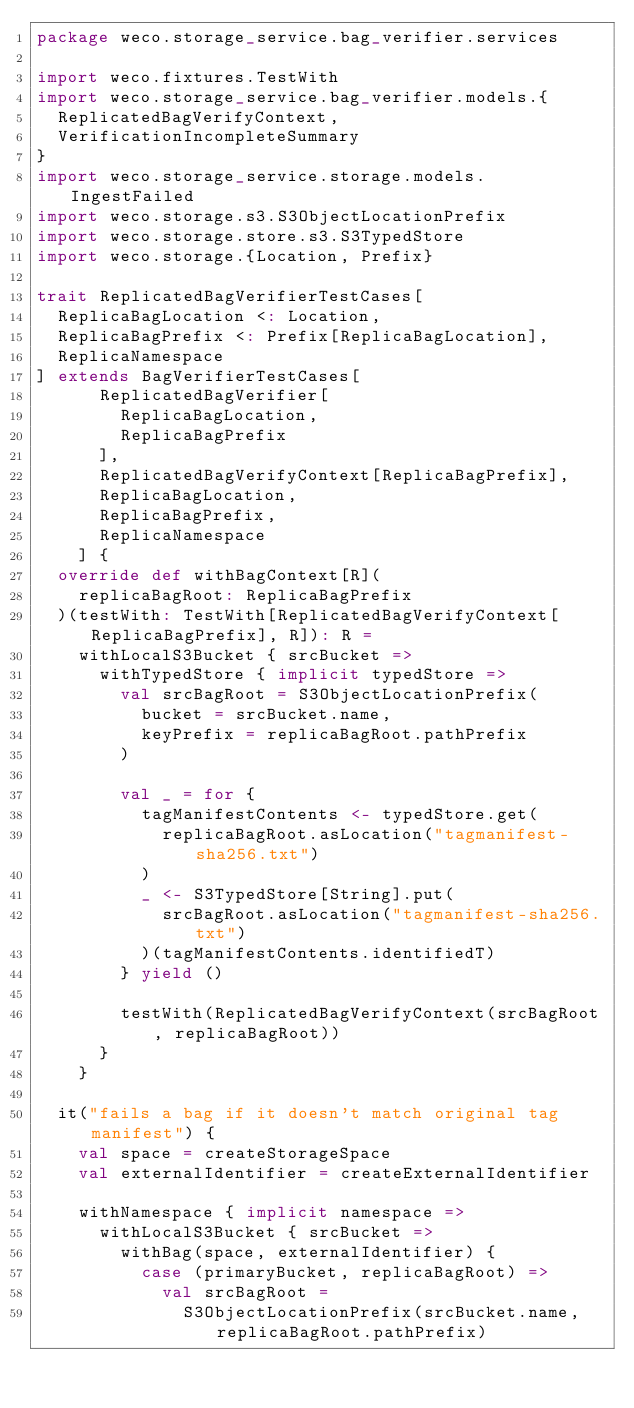<code> <loc_0><loc_0><loc_500><loc_500><_Scala_>package weco.storage_service.bag_verifier.services

import weco.fixtures.TestWith
import weco.storage_service.bag_verifier.models.{
  ReplicatedBagVerifyContext,
  VerificationIncompleteSummary
}
import weco.storage_service.storage.models.IngestFailed
import weco.storage.s3.S3ObjectLocationPrefix
import weco.storage.store.s3.S3TypedStore
import weco.storage.{Location, Prefix}

trait ReplicatedBagVerifierTestCases[
  ReplicaBagLocation <: Location,
  ReplicaBagPrefix <: Prefix[ReplicaBagLocation],
  ReplicaNamespace
] extends BagVerifierTestCases[
      ReplicatedBagVerifier[
        ReplicaBagLocation,
        ReplicaBagPrefix
      ],
      ReplicatedBagVerifyContext[ReplicaBagPrefix],
      ReplicaBagLocation,
      ReplicaBagPrefix,
      ReplicaNamespace
    ] {
  override def withBagContext[R](
    replicaBagRoot: ReplicaBagPrefix
  )(testWith: TestWith[ReplicatedBagVerifyContext[ReplicaBagPrefix], R]): R =
    withLocalS3Bucket { srcBucket =>
      withTypedStore { implicit typedStore =>
        val srcBagRoot = S3ObjectLocationPrefix(
          bucket = srcBucket.name,
          keyPrefix = replicaBagRoot.pathPrefix
        )

        val _ = for {
          tagManifestContents <- typedStore.get(
            replicaBagRoot.asLocation("tagmanifest-sha256.txt")
          )
          _ <- S3TypedStore[String].put(
            srcBagRoot.asLocation("tagmanifest-sha256.txt")
          )(tagManifestContents.identifiedT)
        } yield ()

        testWith(ReplicatedBagVerifyContext(srcBagRoot, replicaBagRoot))
      }
    }

  it("fails a bag if it doesn't match original tag manifest") {
    val space = createStorageSpace
    val externalIdentifier = createExternalIdentifier

    withNamespace { implicit namespace =>
      withLocalS3Bucket { srcBucket =>
        withBag(space, externalIdentifier) {
          case (primaryBucket, replicaBagRoot) =>
            val srcBagRoot =
              S3ObjectLocationPrefix(srcBucket.name, replicaBagRoot.pathPrefix)
</code> 